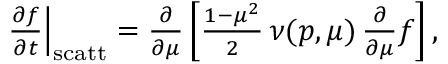Convert formula to latex. <formula><loc_0><loc_0><loc_500><loc_500>\begin{array} { r } { \frac { \partial f } { \partial t } \right | _ { s c a t t } = \frac { \partial } { \partial \mu } \left [ \frac { 1 - \mu ^ { 2 } } { 2 } \, \nu ( p , \mu ) \, \frac { \partial } { \partial \mu } f \right ] , } \end{array}</formula> 